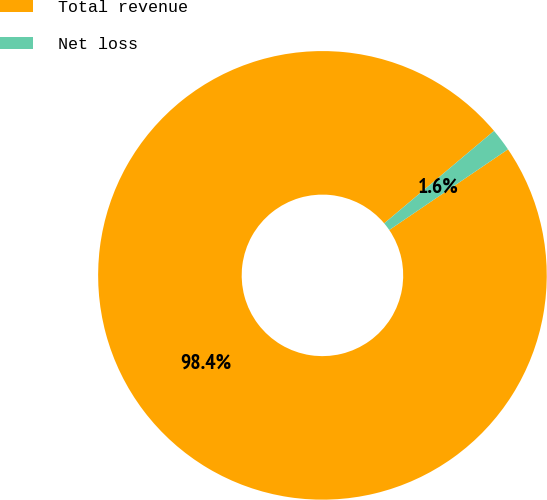Convert chart. <chart><loc_0><loc_0><loc_500><loc_500><pie_chart><fcel>Total revenue<fcel>Net loss<nl><fcel>98.36%<fcel>1.64%<nl></chart> 